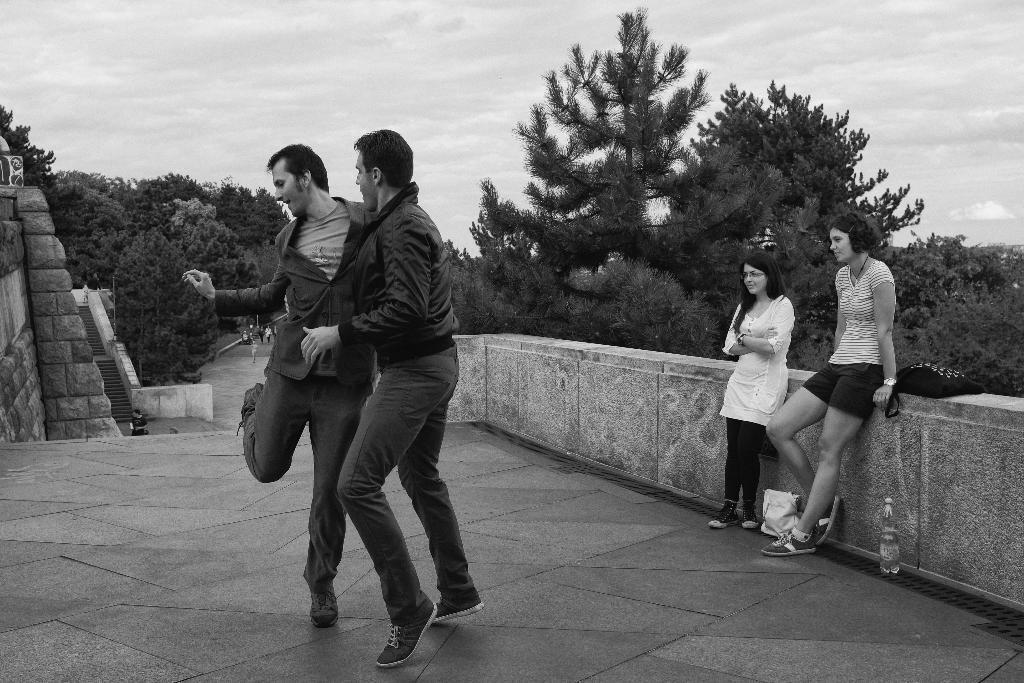How would you summarize this image in a sentence or two? There are two persons dancing on the floor. On the right side, there are two women standing and leaning on the wall near a bottle and handbag these are on the floor. In the background, there are trees, there are steps, there are persons walking on the road and there are clouds in the sky. 